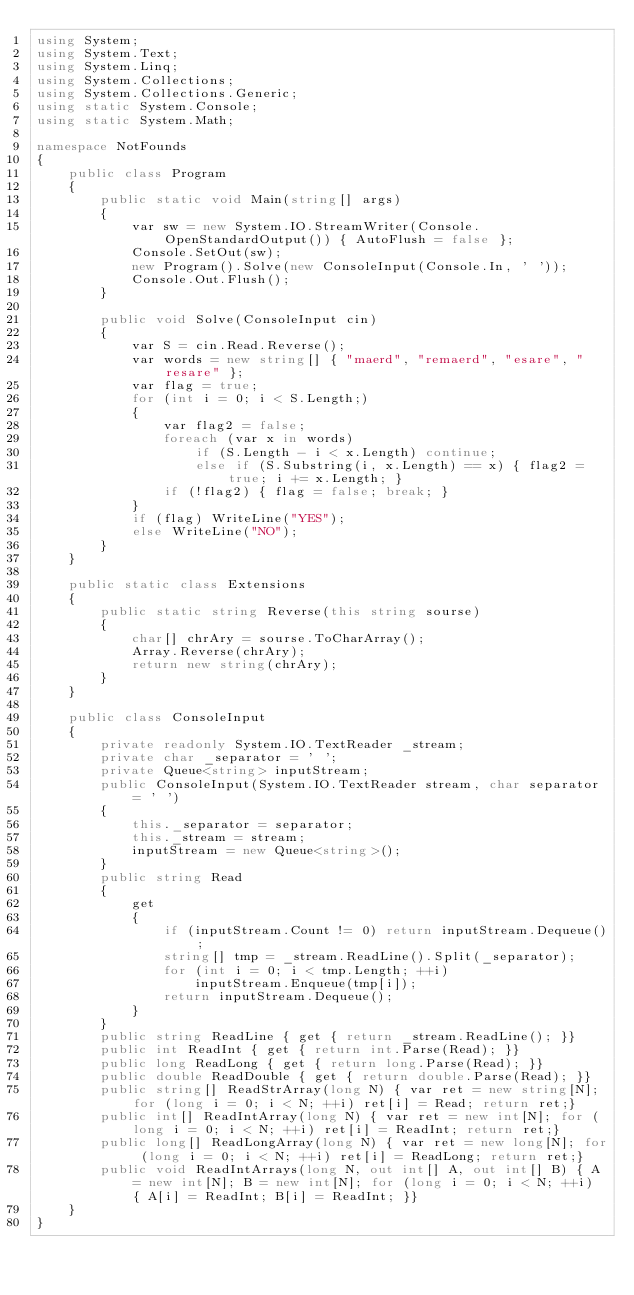Convert code to text. <code><loc_0><loc_0><loc_500><loc_500><_C#_>using System;
using System.Text;
using System.Linq;
using System.Collections;
using System.Collections.Generic;
using static System.Console;
using static System.Math;

namespace NotFounds
{
    public class Program
    {
        public static void Main(string[] args)
        {
            var sw = new System.IO.StreamWriter(Console.OpenStandardOutput()) { AutoFlush = false };
            Console.SetOut(sw);
            new Program().Solve(new ConsoleInput(Console.In, ' '));
            Console.Out.Flush();
        }

        public void Solve(ConsoleInput cin)
        {
            var S = cin.Read.Reverse();
            var words = new string[] { "maerd", "remaerd", "esare", "resare" };
            var flag = true;
            for (int i = 0; i < S.Length;)
            {
                var flag2 = false;
                foreach (var x in words)
                    if (S.Length - i < x.Length) continue;
                    else if (S.Substring(i, x.Length) == x) { flag2 = true; i += x.Length; }
                if (!flag2) { flag = false; break; }
            }
            if (flag) WriteLine("YES");
            else WriteLine("NO");
        }
    }

    public static class Extensions
    {
        public static string Reverse(this string sourse)
        {
            char[] chrAry = sourse.ToCharArray();
            Array.Reverse(chrAry);
            return new string(chrAry);
        }
    }

    public class ConsoleInput
    {
        private readonly System.IO.TextReader _stream;
        private char _separator = ' ';
        private Queue<string> inputStream;
        public ConsoleInput(System.IO.TextReader stream, char separator = ' ')
        {
            this._separator = separator;
            this._stream = stream;
            inputStream = new Queue<string>();
        }
        public string Read
        {
            get
            {
                if (inputStream.Count != 0) return inputStream.Dequeue();
                string[] tmp = _stream.ReadLine().Split(_separator);
                for (int i = 0; i < tmp.Length; ++i)
                    inputStream.Enqueue(tmp[i]);
                return inputStream.Dequeue();
            }
        }
        public string ReadLine { get { return _stream.ReadLine(); }}
        public int ReadInt { get { return int.Parse(Read); }}
        public long ReadLong { get { return long.Parse(Read); }}
        public double ReadDouble { get { return double.Parse(Read); }}
        public string[] ReadStrArray(long N) { var ret = new string[N]; for (long i = 0; i < N; ++i) ret[i] = Read; return ret;}
        public int[] ReadIntArray(long N) { var ret = new int[N]; for (long i = 0; i < N; ++i) ret[i] = ReadInt; return ret;}
        public long[] ReadLongArray(long N) { var ret = new long[N]; for (long i = 0; i < N; ++i) ret[i] = ReadLong; return ret;}
        public void ReadIntArrays(long N, out int[] A, out int[] B) { A = new int[N]; B = new int[N]; for (long i = 0; i < N; ++i) { A[i] = ReadInt; B[i] = ReadInt; }}
    }
}
</code> 